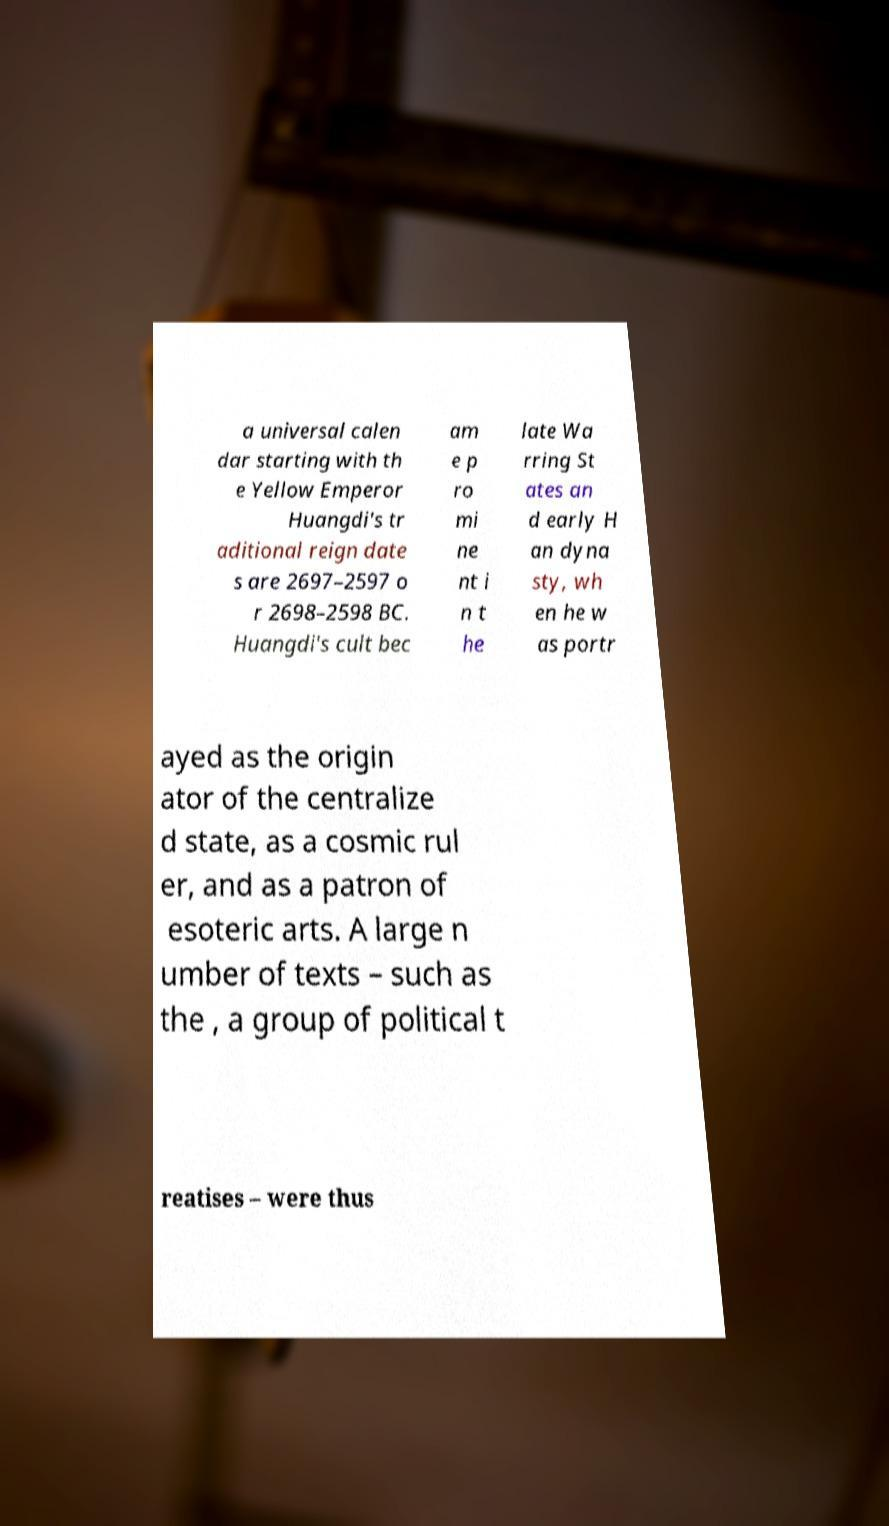Can you read and provide the text displayed in the image?This photo seems to have some interesting text. Can you extract and type it out for me? a universal calen dar starting with th e Yellow Emperor Huangdi's tr aditional reign date s are 2697–2597 o r 2698–2598 BC. Huangdi's cult bec am e p ro mi ne nt i n t he late Wa rring St ates an d early H an dyna sty, wh en he w as portr ayed as the origin ator of the centralize d state, as a cosmic rul er, and as a patron of esoteric arts. A large n umber of texts – such as the , a group of political t reatises – were thus 